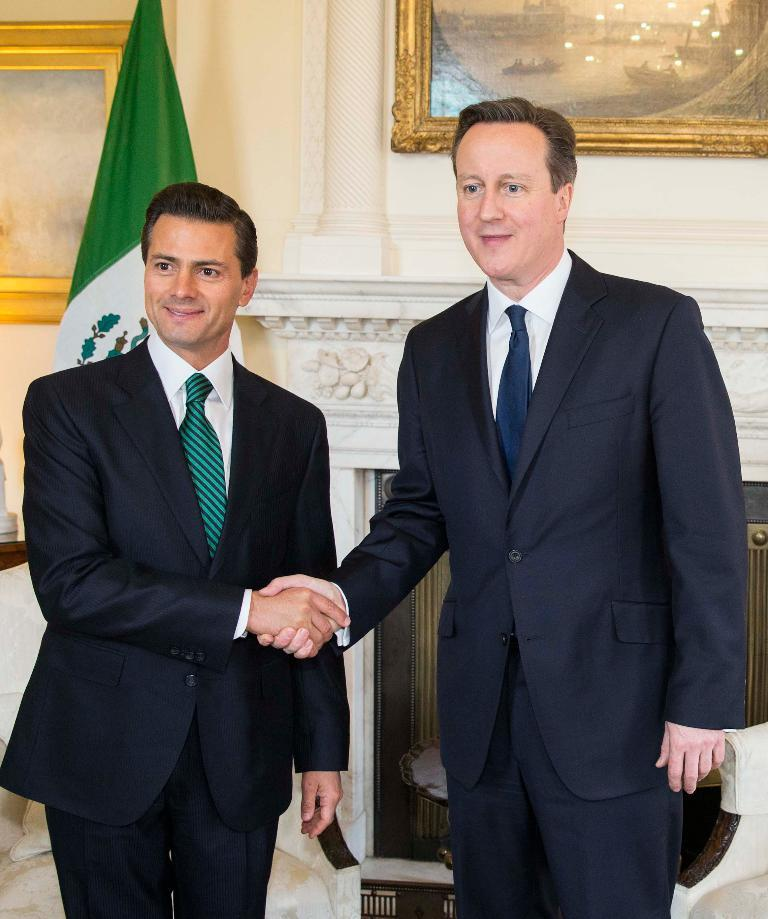How many men are in the image? There are two men in the image. What are the men wearing? Both men are wearing blazers and ties. What are the men doing in the image? The men are standing and smiling. What can be seen in the background of the image? There is a flag and frames on the wall in the background of the image. What time does the rule hope to enforce in the image? There is no mention of time, rule, or hope in the image. The image features two men in blazers and ties, standing and smiling, with a flag and frames on the wall in the background. 